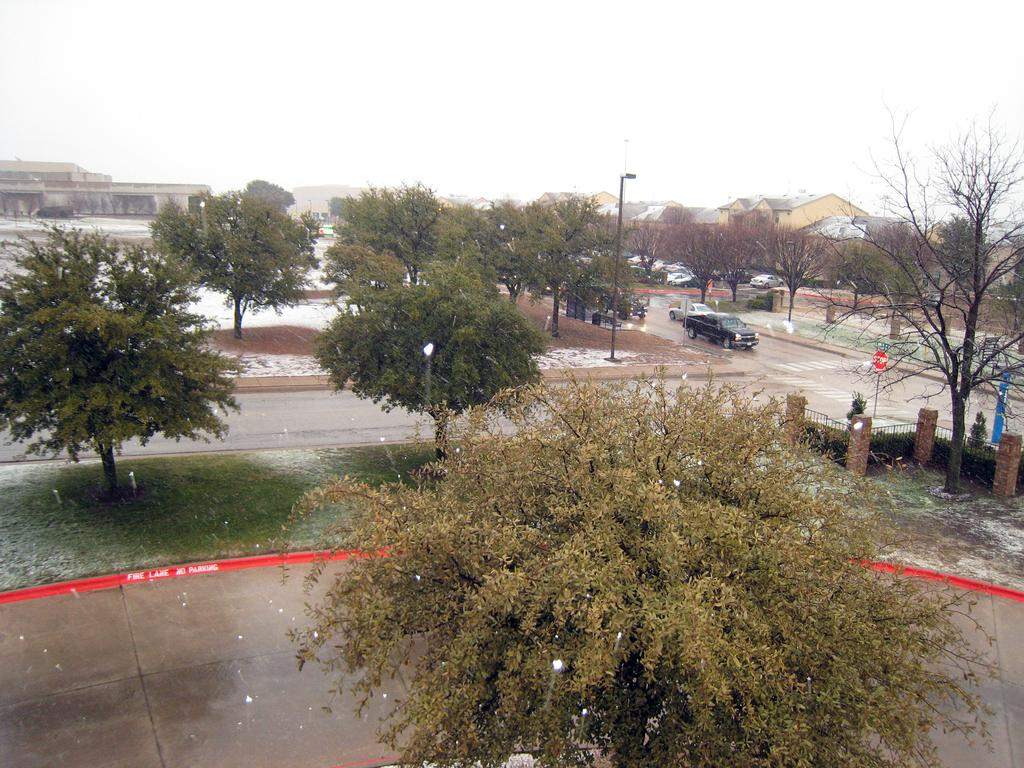What type of vegetation can be seen in the image? There is a group of trees in the image. What else can be seen in the image besides the trees? There are vehicles, fencing, a street pole, grass, buildings, and the sky visible in the image. What might be used to separate or enclose an area in the image? The fencing in the image might be used to separate or enclose an area. What is the background of the image composed of? The background of the image is composed of buildings and the sky. What type of cord is being used to drive the vehicles in the image? There is no cord present in the image, and the vehicles are not being driven by any visible means. 